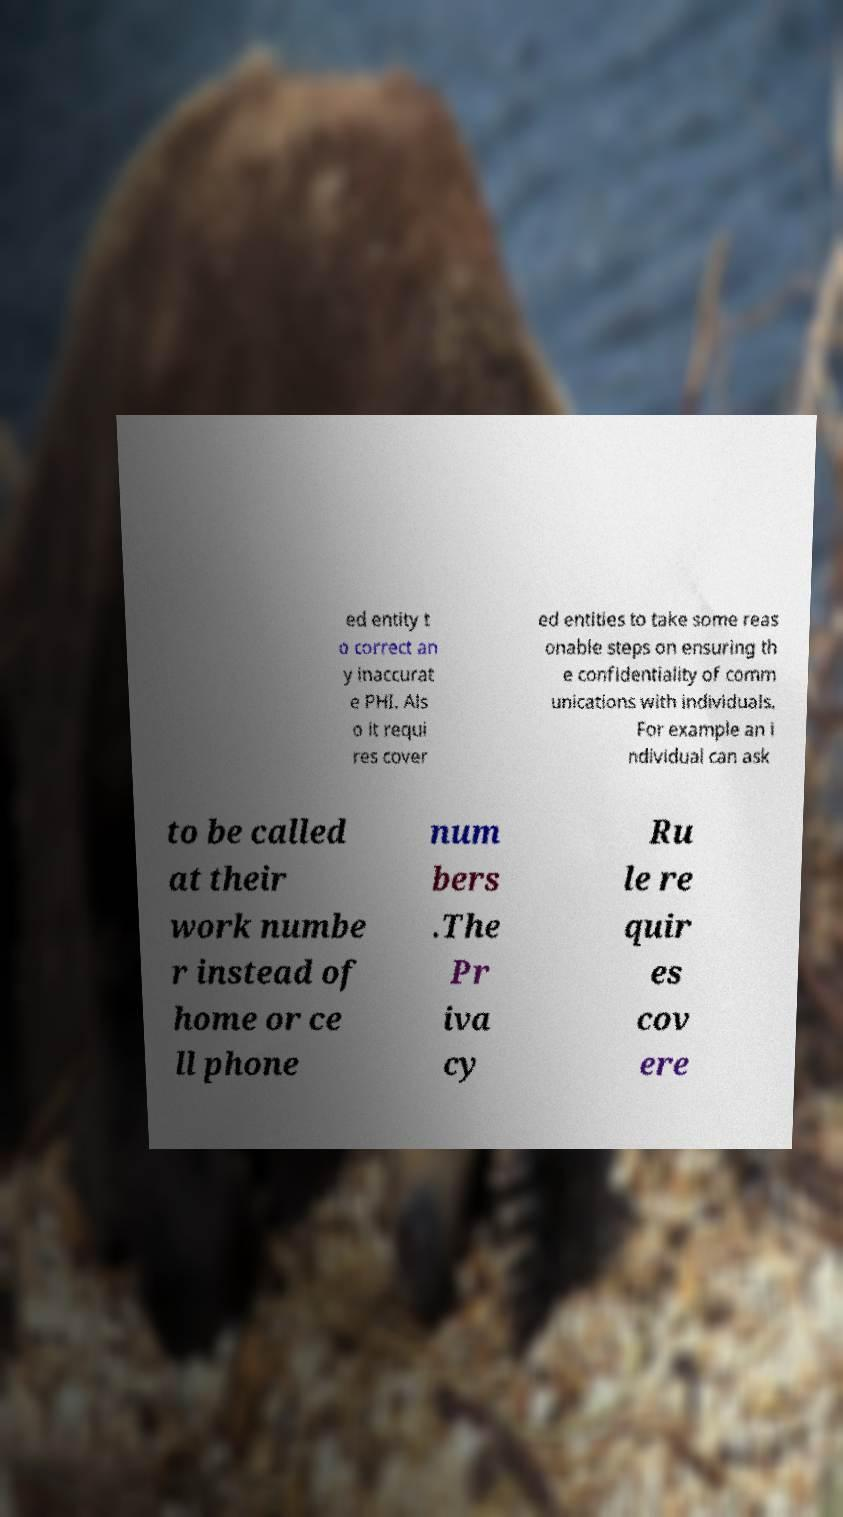I need the written content from this picture converted into text. Can you do that? ed entity t o correct an y inaccurat e PHI. Als o it requi res cover ed entities to take some reas onable steps on ensuring th e confidentiality of comm unications with individuals. For example an i ndividual can ask to be called at their work numbe r instead of home or ce ll phone num bers .The Pr iva cy Ru le re quir es cov ere 